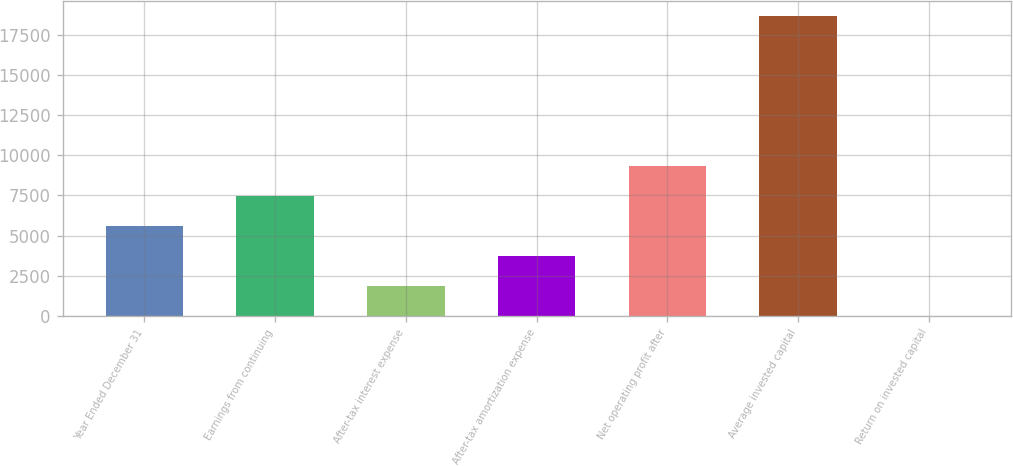Convert chart to OTSL. <chart><loc_0><loc_0><loc_500><loc_500><bar_chart><fcel>Year Ended December 31<fcel>Earnings from continuing<fcel>After-tax interest expense<fcel>After-tax amortization expense<fcel>Net operating profit after<fcel>Average invested capital<fcel>Return on invested capital<nl><fcel>5618.17<fcel>7485.86<fcel>1882.79<fcel>3750.48<fcel>9353.55<fcel>18692<fcel>15.1<nl></chart> 